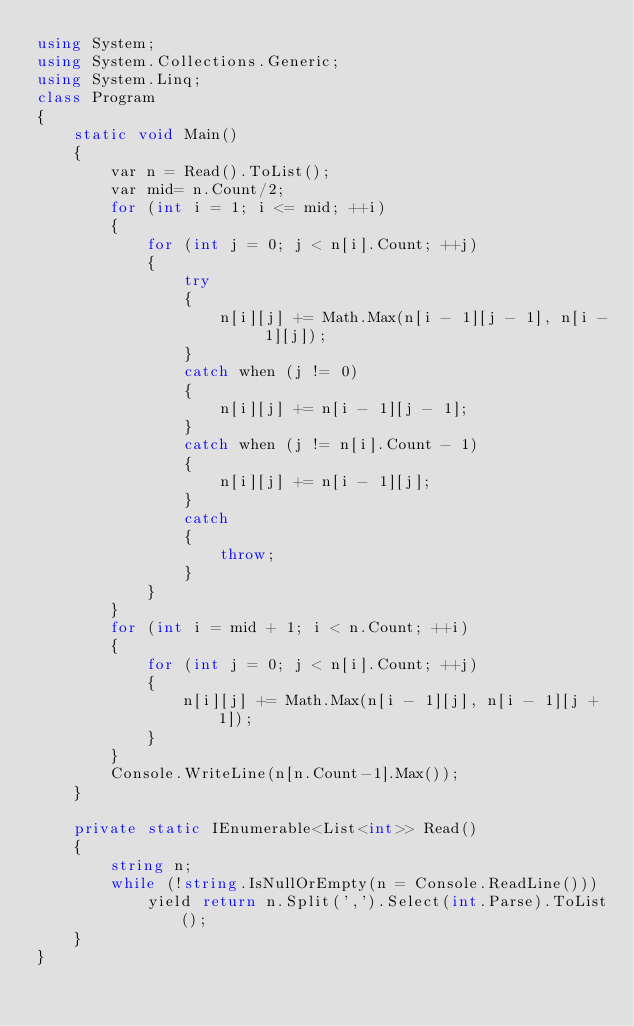Convert code to text. <code><loc_0><loc_0><loc_500><loc_500><_C#_>using System;
using System.Collections.Generic;
using System.Linq;
class Program
{
    static void Main()
    {
        var n = Read().ToList();
        var mid= n.Count/2;
        for (int i = 1; i <= mid; ++i)
        {
            for (int j = 0; j < n[i].Count; ++j)
            {
                try
                {
                    n[i][j] += Math.Max(n[i - 1][j - 1], n[i - 1][j]);
                }
                catch when (j != 0)
                {
                    n[i][j] += n[i - 1][j - 1];
                }
                catch when (j != n[i].Count - 1)
                {
                    n[i][j] += n[i - 1][j];
                }
                catch
                {
                    throw;
                }
            }
        }
        for (int i = mid + 1; i < n.Count; ++i)
        {
            for (int j = 0; j < n[i].Count; ++j)
            {
                n[i][j] += Math.Max(n[i - 1][j], n[i - 1][j + 1]);
            }
        }
        Console.WriteLine(n[n.Count-1].Max());
    }

    private static IEnumerable<List<int>> Read()
    {
        string n;
        while (!string.IsNullOrEmpty(n = Console.ReadLine()))
            yield return n.Split(',').Select(int.Parse).ToList();
    }
}
</code> 